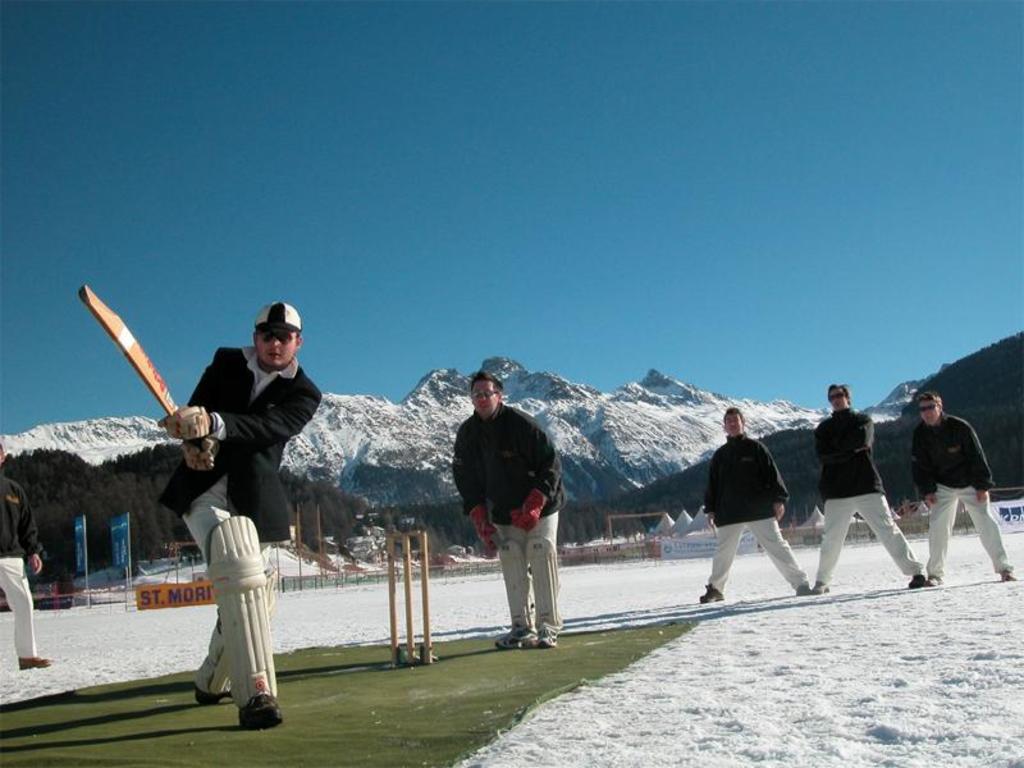Could you give a brief overview of what you see in this image? In this image we can see a group of men standing on the ground. In that a man is holding a bat. We can also see the stumps, banners, snow, poles, a board with some text on it, some tents, a group of trees, the ice hills and the sky. 